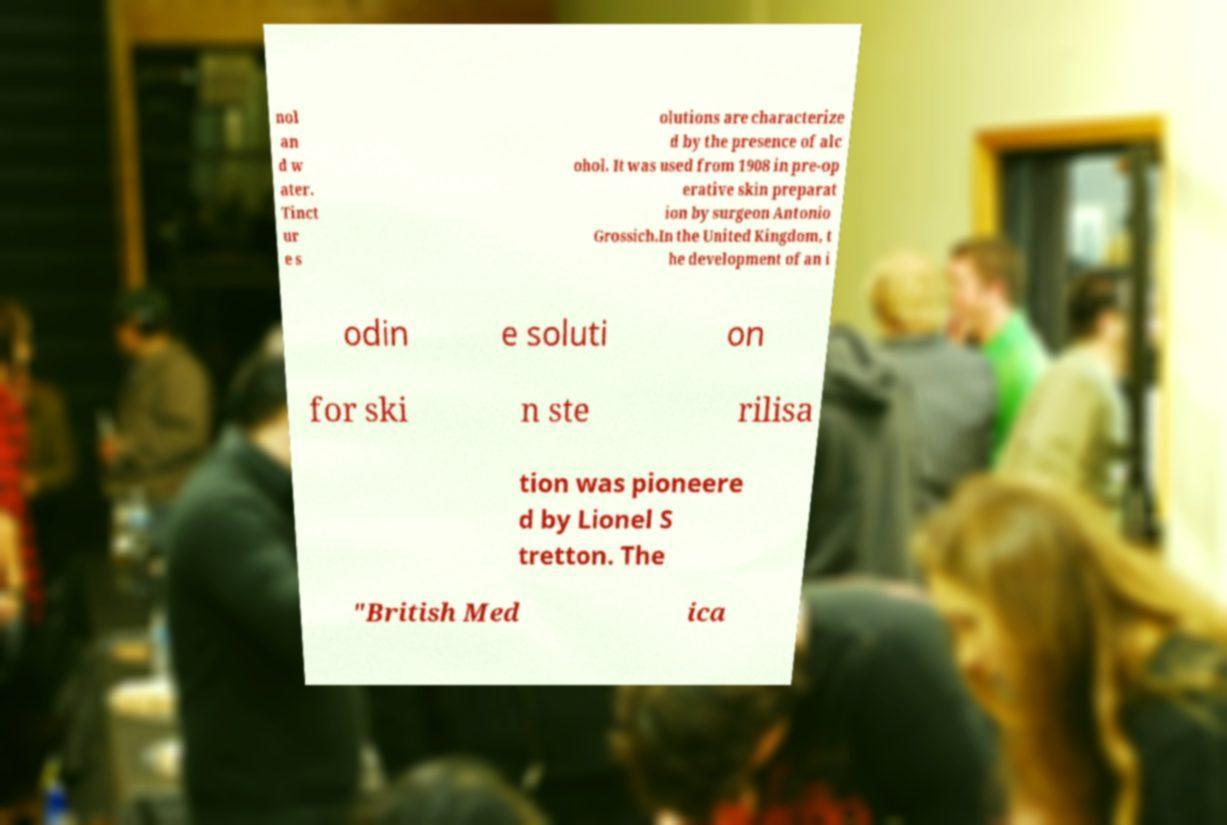Please read and relay the text visible in this image. What does it say? nol an d w ater. Tinct ur e s olutions are characterize d by the presence of alc ohol. It was used from 1908 in pre-op erative skin preparat ion by surgeon Antonio Grossich.In the United Kingdom, t he development of an i odin e soluti on for ski n ste rilisa tion was pioneere d by Lionel S tretton. The "British Med ica 